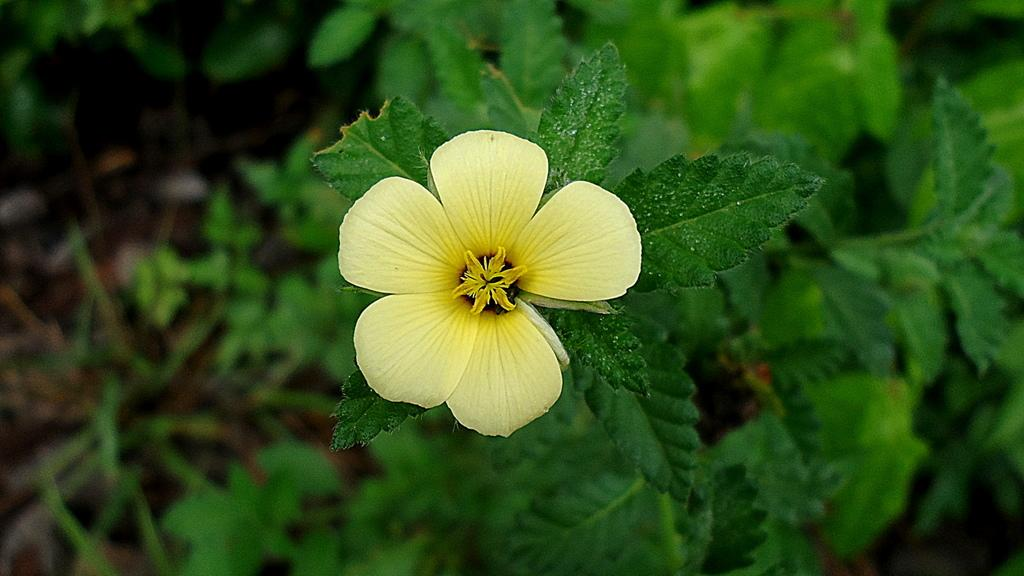What is the main subject of the image? There is a flower in the middle of the image. What can be seen in the background of the image? There are plants in the background of the image. What type of sound can be heard coming from the glass in the image? There is no glass present in the image, so it is not possible to determine what, if any, sound might be heard. 